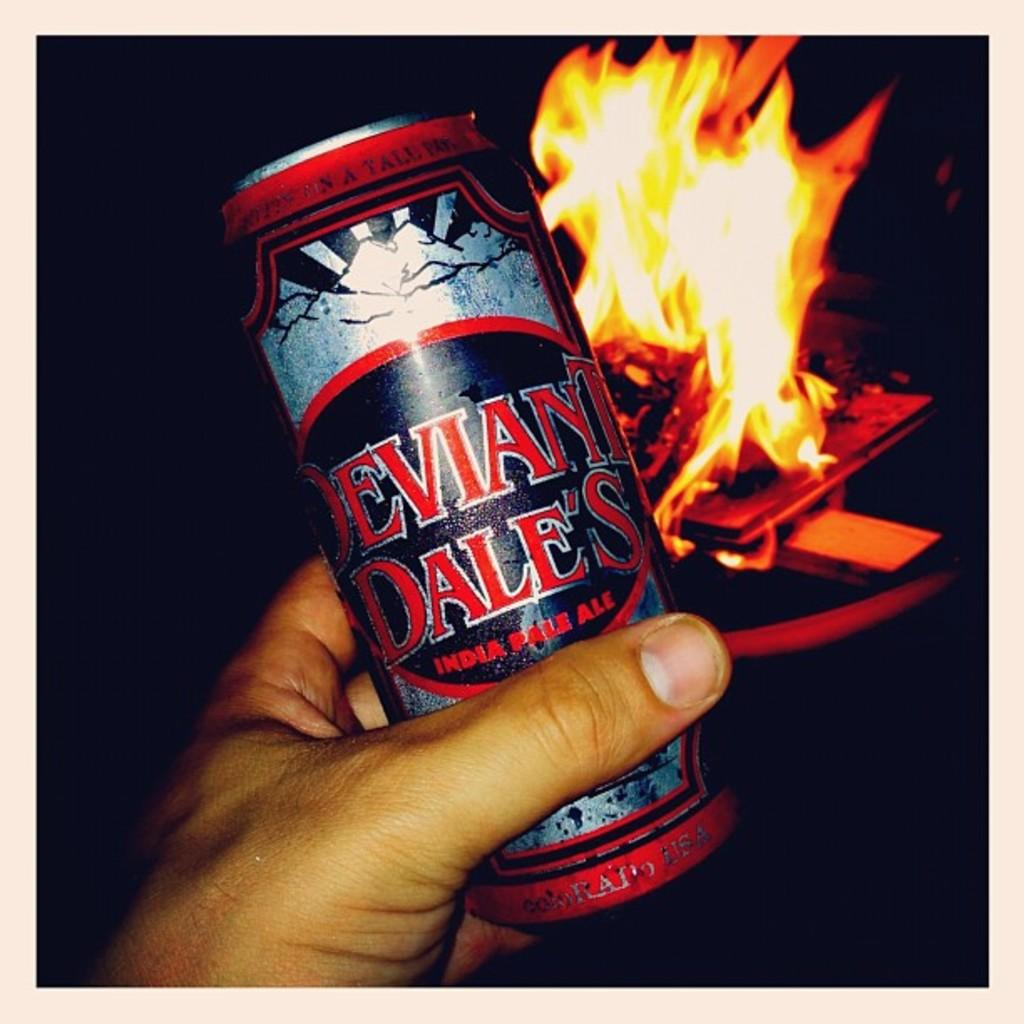<image>
Present a compact description of the photo's key features. Person holding a can which says "DALES" on it. 